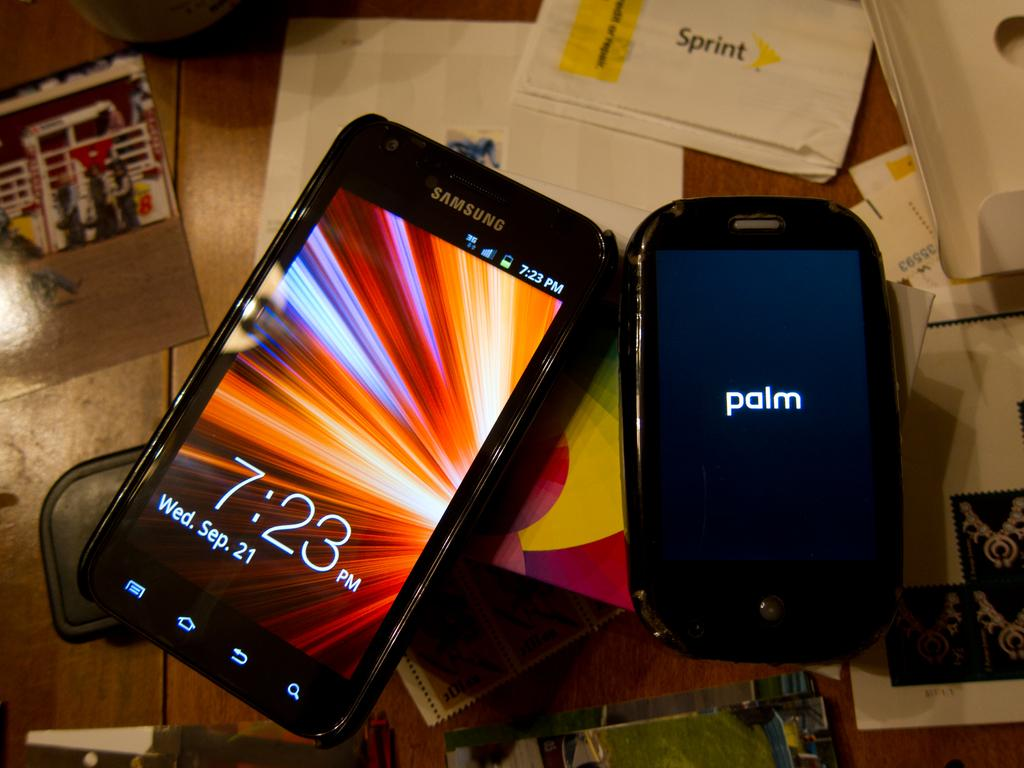What type of objects can be seen in the image? There are mobiles, photos, and many papers in the image. What can be inferred about the purpose of the mobiles and photos? The mobiles and photos may be used for decoration or displaying personal items. What is the color of the surface where the items are placed? The surface is brown in color. Can you see any suggestions written on the papers in the image? There is no information about the content of the papers in the image, so it cannot be determined if there are any suggestions written on them. 